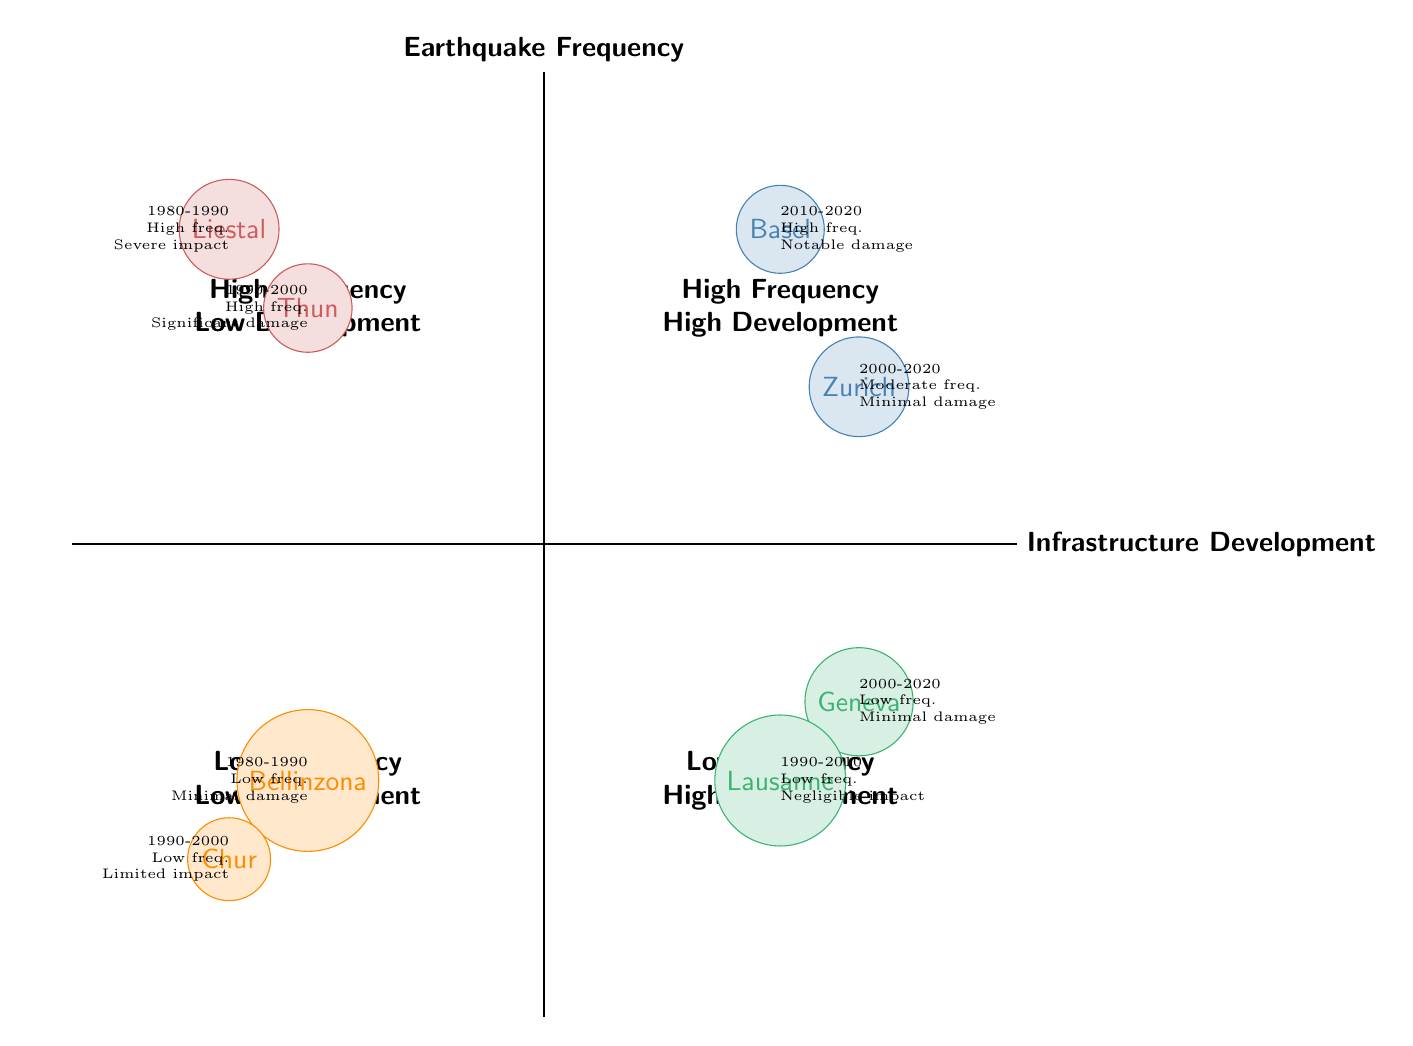What cities are located in the "High Earthquake Frequency - High Infrastructure Development" quadrant? The diagram indicates that Zurich and Basel are located in the "High Earthquake Frequency - High Infrastructure Development" quadrant.
Answer: Zurich, Basel What is the earthquake frequency for Thun during the period 1990-2000? According to the diagram, Thun's earthquake frequency during 1990-2000 is classified as High.
Answer: High How many cities are categorized under "Low Earthquake Frequency - Low Infrastructure Development"? From the diagram, there are two cities in the "Low Earthquake Frequency - Low Infrastructure Development" quadrant: Bellinzona and Chur.
Answer: 2 What infrastructure projects were undertaken in Geneva between 2000-2020? The diagram lists two infrastructure projects for Geneva from 2000-2020: LED streetlight replacements and Cornavin Station Renovation.
Answer: LED streetlight replacements, Cornavin Station Renovation Which city experienced "significant damage to historical buildings" due to high earthquake frequency with low infrastructure development? The diagram indicates that Thun experienced "significant damage to historical buildings" in the context of "High Earthquake Frequency - Low Infrastructure Development."
Answer: Thun What is the impact of the infrastructure projects in Zurich from 2000-2020? The diagram states that the impact of infrastructure projects in Zurich from 2000-2020 is "Minimal structural damage, high community resilience."
Answer: Minimal structural damage, high community resilience Which quadrant has a city with "negligible earthquake impact"? According to the diagram, Lausanne is located in the "Low Earthquake Frequency - High Infrastructure Development" quadrant, and it has "negligible earthquake impact."
Answer: Low Earthquake Frequency - High Infrastructure Development What was the earthquake frequency in Basel from 2010-2020, and what was the impact? The diagram shows that Basel had a High earthquake frequency, and the impact of this was "Notable damage to older structures, high construction standards mitigate risks."
Answer: High, Notable damage to older structures What infrastructure projects were carried out in Liestal between 1980-1990? The diagram specifies that Liestal undertook a "Community center" as an infrastructure project between 1980-1990.
Answer: Community center 